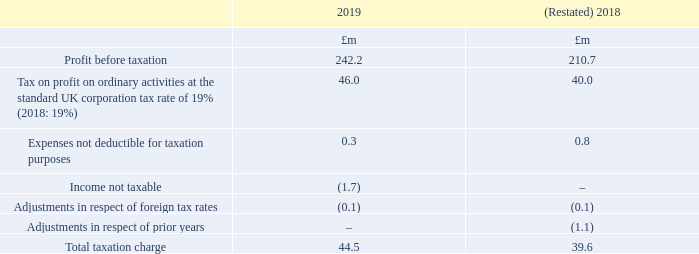11. Taxation
The taxation charge for the year is lower than (2018: the same as) the effective rate of corporation tax in the UK of 19% (2018: 19%). The differences are explained below:
Taxation on items taken directly to equity was a credit of £0.6m (2018: £0.1m) relating to tax on share-based payments.
The tax charge for the year is based on the standard rate of UK corporation tax for the period of 19% (2018: 19%). Deferred income taxes have been measured at the tax rate expected to be applicable at the date the deferred income tax assets and liabilities are realised. Management has performed an assessment, for all material deferred income tax assets and liabilities, to determine the period over which the deferred income tax assets and liabilities are forecast to be realised, which has resulted in an average deferred income tax rate of 17% being used to measure all deferred tax balances as at 31 March 2019 (2018: 17%).
What was the Taxation on items taken directly to equity? A credit of £0.6m (2018: £0.1m) relating to tax on share-based payments. What was the effective rate of corporation tax in the UK? 19%. For which years was the total taxation charge calculated in? 2019, 2018. In which year was Expenses not deductible for taxation purposes larger? 0.8>0.3
Answer: 2018. What was the change in Total taxation charge in 2019 from 2018?
Answer scale should be: million. 44.5-39.6
Answer: 4.9. What was the percentage change in Total taxation charge in 2019 from 2018?
Answer scale should be: percent. (44.5-39.6)/39.6
Answer: 12.37. 